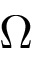Convert formula to latex. <formula><loc_0><loc_0><loc_500><loc_500>\Omega</formula> 